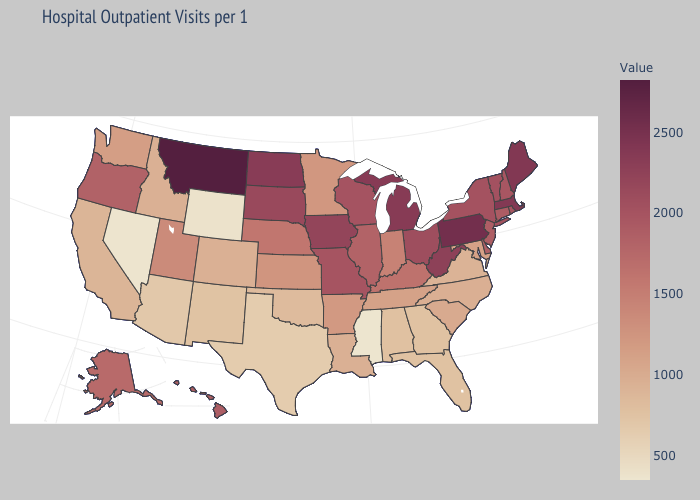Which states have the highest value in the USA?
Give a very brief answer. Montana. Does Missouri have a lower value than Arkansas?
Concise answer only. No. Does South Carolina have a higher value than Wyoming?
Be succinct. Yes. Does the map have missing data?
Write a very short answer. No. Does Maryland have a lower value than Oklahoma?
Short answer required. No. Among the states that border Oklahoma , does Texas have the lowest value?
Give a very brief answer. Yes. Among the states that border New Jersey , does Delaware have the highest value?
Give a very brief answer. No. 